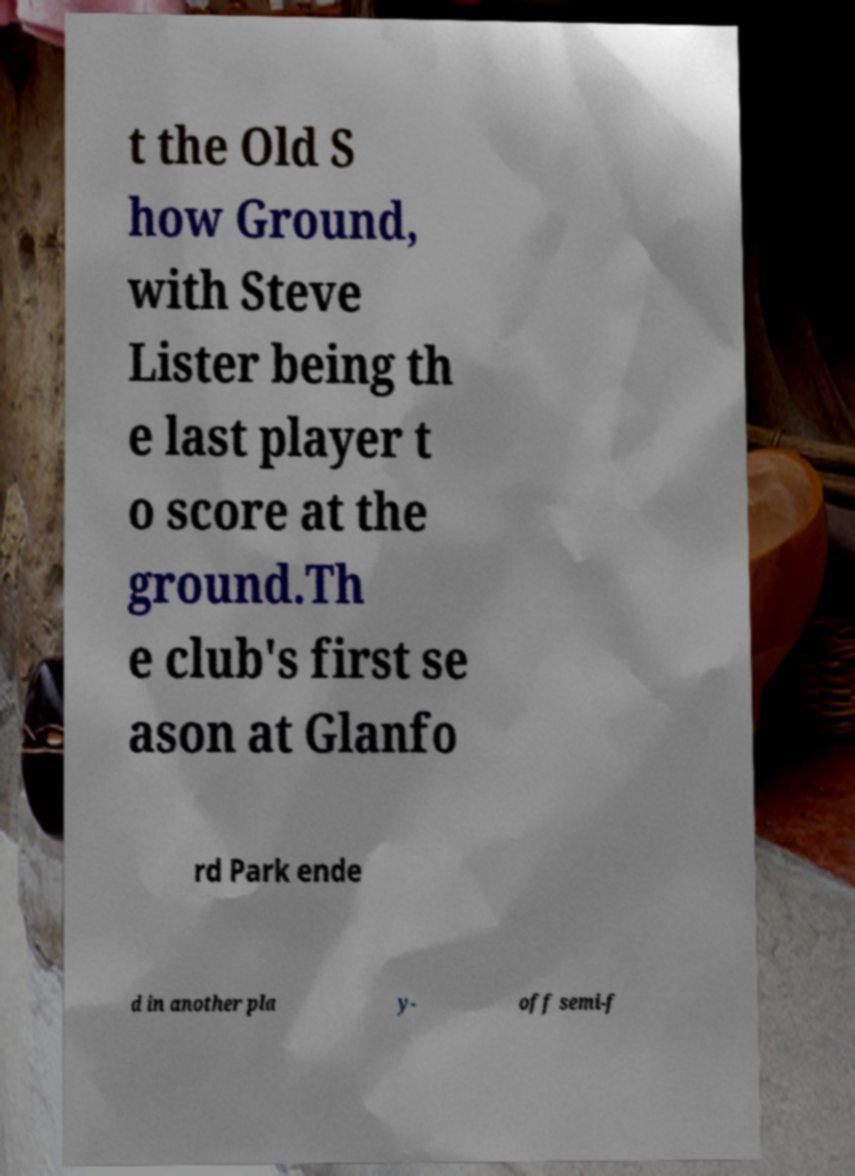What messages or text are displayed in this image? I need them in a readable, typed format. t the Old S how Ground, with Steve Lister being th e last player t o score at the ground.Th e club's first se ason at Glanfo rd Park ende d in another pla y- off semi-f 